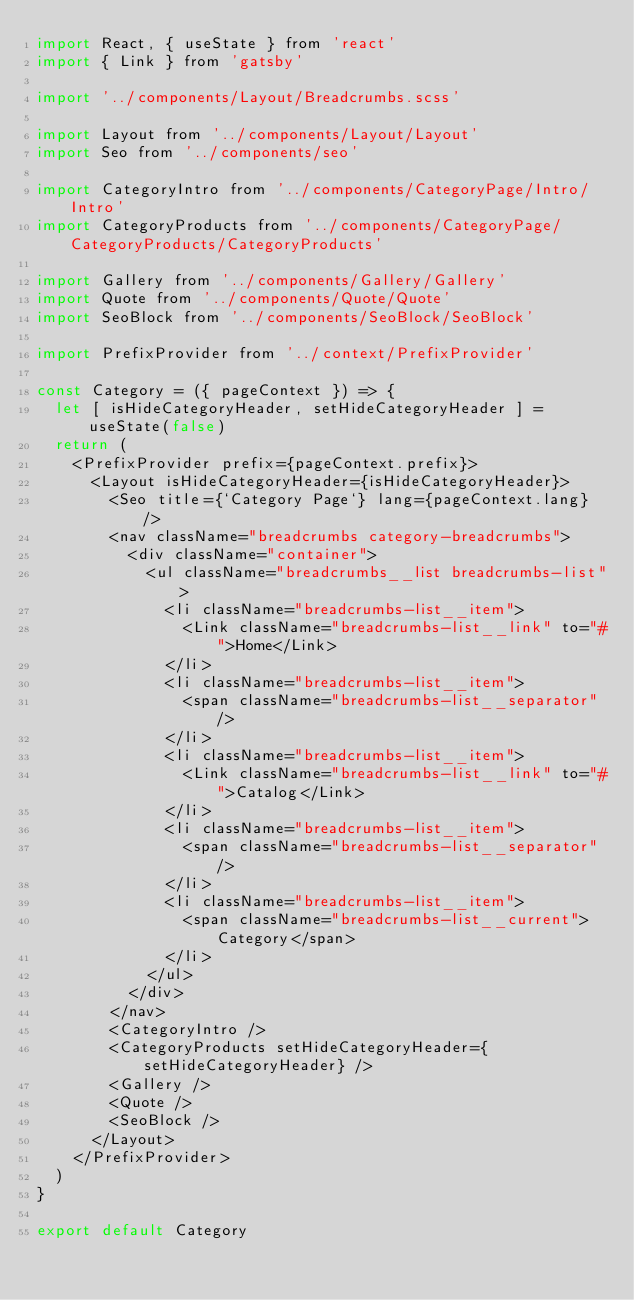<code> <loc_0><loc_0><loc_500><loc_500><_JavaScript_>import React, { useState } from 'react'
import { Link } from 'gatsby'

import '../components/Layout/Breadcrumbs.scss'

import Layout from '../components/Layout/Layout'
import Seo from '../components/seo'

import CategoryIntro from '../components/CategoryPage/Intro/Intro'
import CategoryProducts from '../components/CategoryPage/CategoryProducts/CategoryProducts'

import Gallery from '../components/Gallery/Gallery'
import Quote from '../components/Quote/Quote'
import SeoBlock from '../components/SeoBlock/SeoBlock'

import PrefixProvider from '../context/PrefixProvider'

const Category = ({ pageContext }) => {
  let [ isHideCategoryHeader, setHideCategoryHeader ] = useState(false)
  return (
    <PrefixProvider prefix={pageContext.prefix}>
      <Layout isHideCategoryHeader={isHideCategoryHeader}>
        <Seo title={`Category Page`} lang={pageContext.lang} />
        <nav className="breadcrumbs category-breadcrumbs">
          <div className="container">
            <ul className="breadcrumbs__list breadcrumbs-list">
              <li className="breadcrumbs-list__item">
                <Link className="breadcrumbs-list__link" to="#">Home</Link>
              </li>
              <li className="breadcrumbs-list__item">
                <span className="breadcrumbs-list__separator" />
              </li>
              <li className="breadcrumbs-list__item">
                <Link className="breadcrumbs-list__link" to="#">Catalog</Link>
              </li>
              <li className="breadcrumbs-list__item">
                <span className="breadcrumbs-list__separator" />
              </li>
              <li className="breadcrumbs-list__item">
                <span className="breadcrumbs-list__current">Category</span>
              </li>
            </ul>
          </div>
        </nav>
        <CategoryIntro />
        <CategoryProducts setHideCategoryHeader={setHideCategoryHeader} />
        <Gallery />
        <Quote />
        <SeoBlock />
      </Layout>
    </PrefixProvider>
  )
}

export default Category</code> 